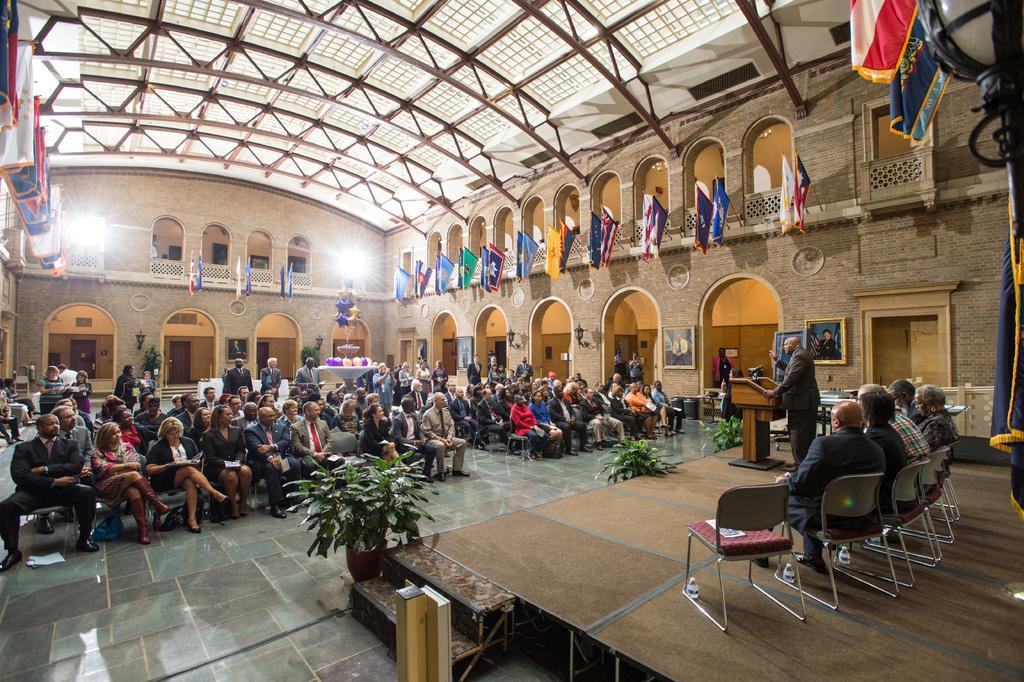Can you describe this image briefly? In this image I can see few people sitting on the chairs and one person standing in-front of the podium. In-front of these people I can see the flower pots and the group of people with different color dresses. To the right I can see the frames attached to the wall. I can see many flags and their the lights to the wall. 